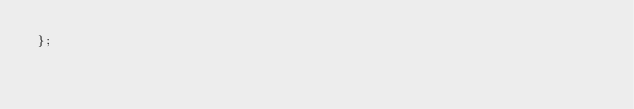<code> <loc_0><loc_0><loc_500><loc_500><_JavaScript_>};</code> 